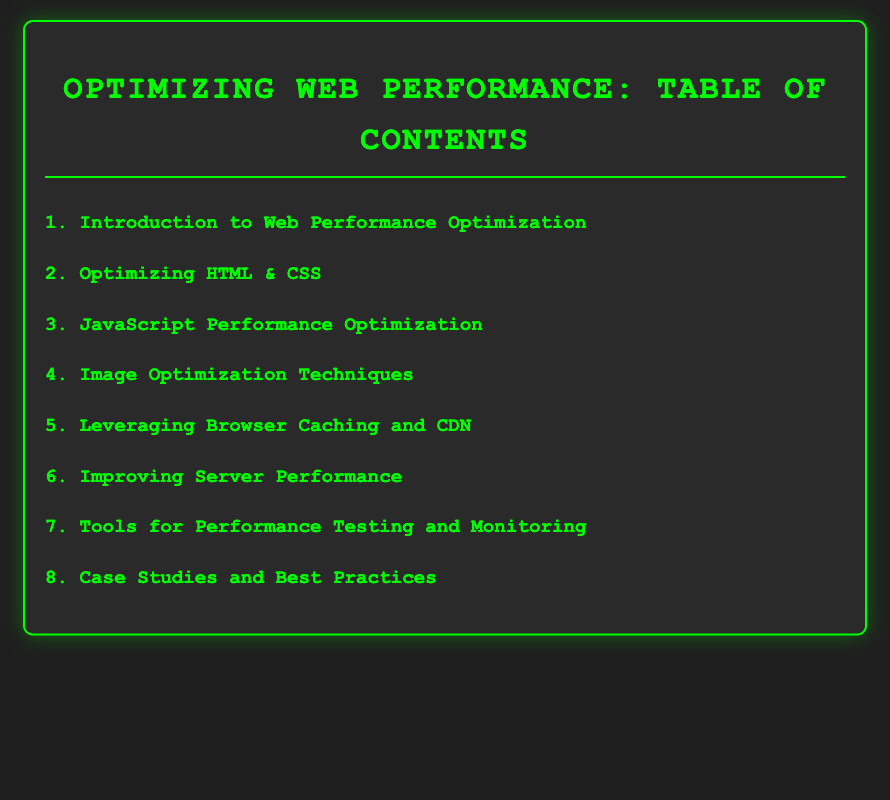What is the first title in the Table of Contents? The first title is the initial section listed in the Table of Contents.
Answer: Introduction to Web Performance Optimization How many subsections are under "Optimizing HTML & CSS"? This is determined by counting the subsections listed under the "Optimizing HTML & CSS" section.
Answer: 3 What section comes after "Leveraging Browser Caching and CDN"? The next section is identified by its order in the Table of Contents.
Answer: Improving Server Performance Which tool is mentioned for performance testing? This is a specific tool listed in the "Tools for Performance Testing and Monitoring" section.
Answer: Google Lighthouse How many total sections are included in the Table of Contents? The total sections refer to how many unique topics are mentioned in the document.
Answer: 8 What key metric is emphasized in the introduction to web performance? This requires understanding which important aspect is highlighted in the "Introduction to Web Performance Optimization."
Answer: Key Metrics to Measure Performance Which optimization technique involves using responsive images? This method is specifically listed under the "Image Optimization Techniques" section.
Answer: Using Responsive Images Which subsection describes server response optimization? It relates to the subsection in "Improving Server Performance" that addresses server efficiency.
Answer: Optimizing Server Response Times What is the last section in the Table of Contents? This is determined by identifying the final topic listed in the document.
Answer: Case Studies and Best Practices 